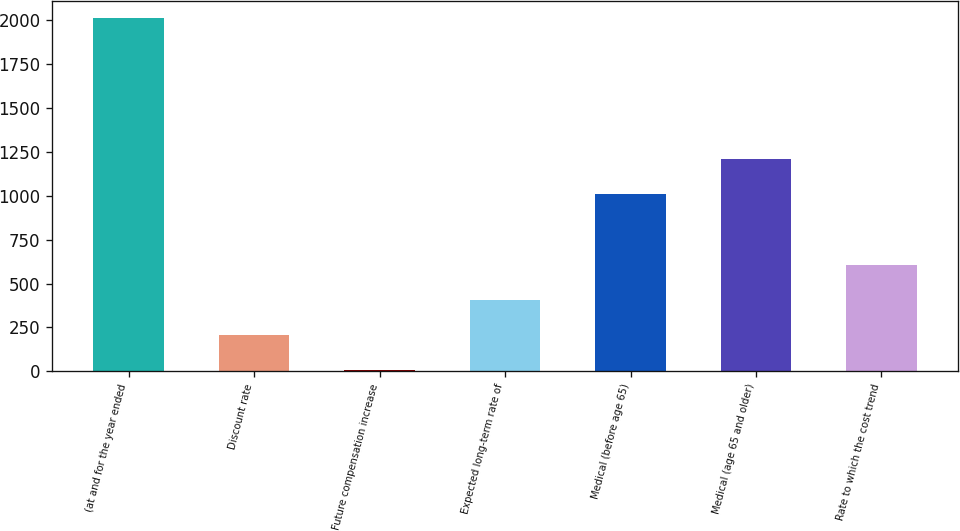Convert chart to OTSL. <chart><loc_0><loc_0><loc_500><loc_500><bar_chart><fcel>(at and for the year ended<fcel>Discount rate<fcel>Future compensation increase<fcel>Expected long-term rate of<fcel>Medical (before age 65)<fcel>Medical (age 65 and older)<fcel>Rate to which the cost trend<nl><fcel>2012<fcel>204.8<fcel>4<fcel>405.6<fcel>1008<fcel>1208.8<fcel>606.4<nl></chart> 